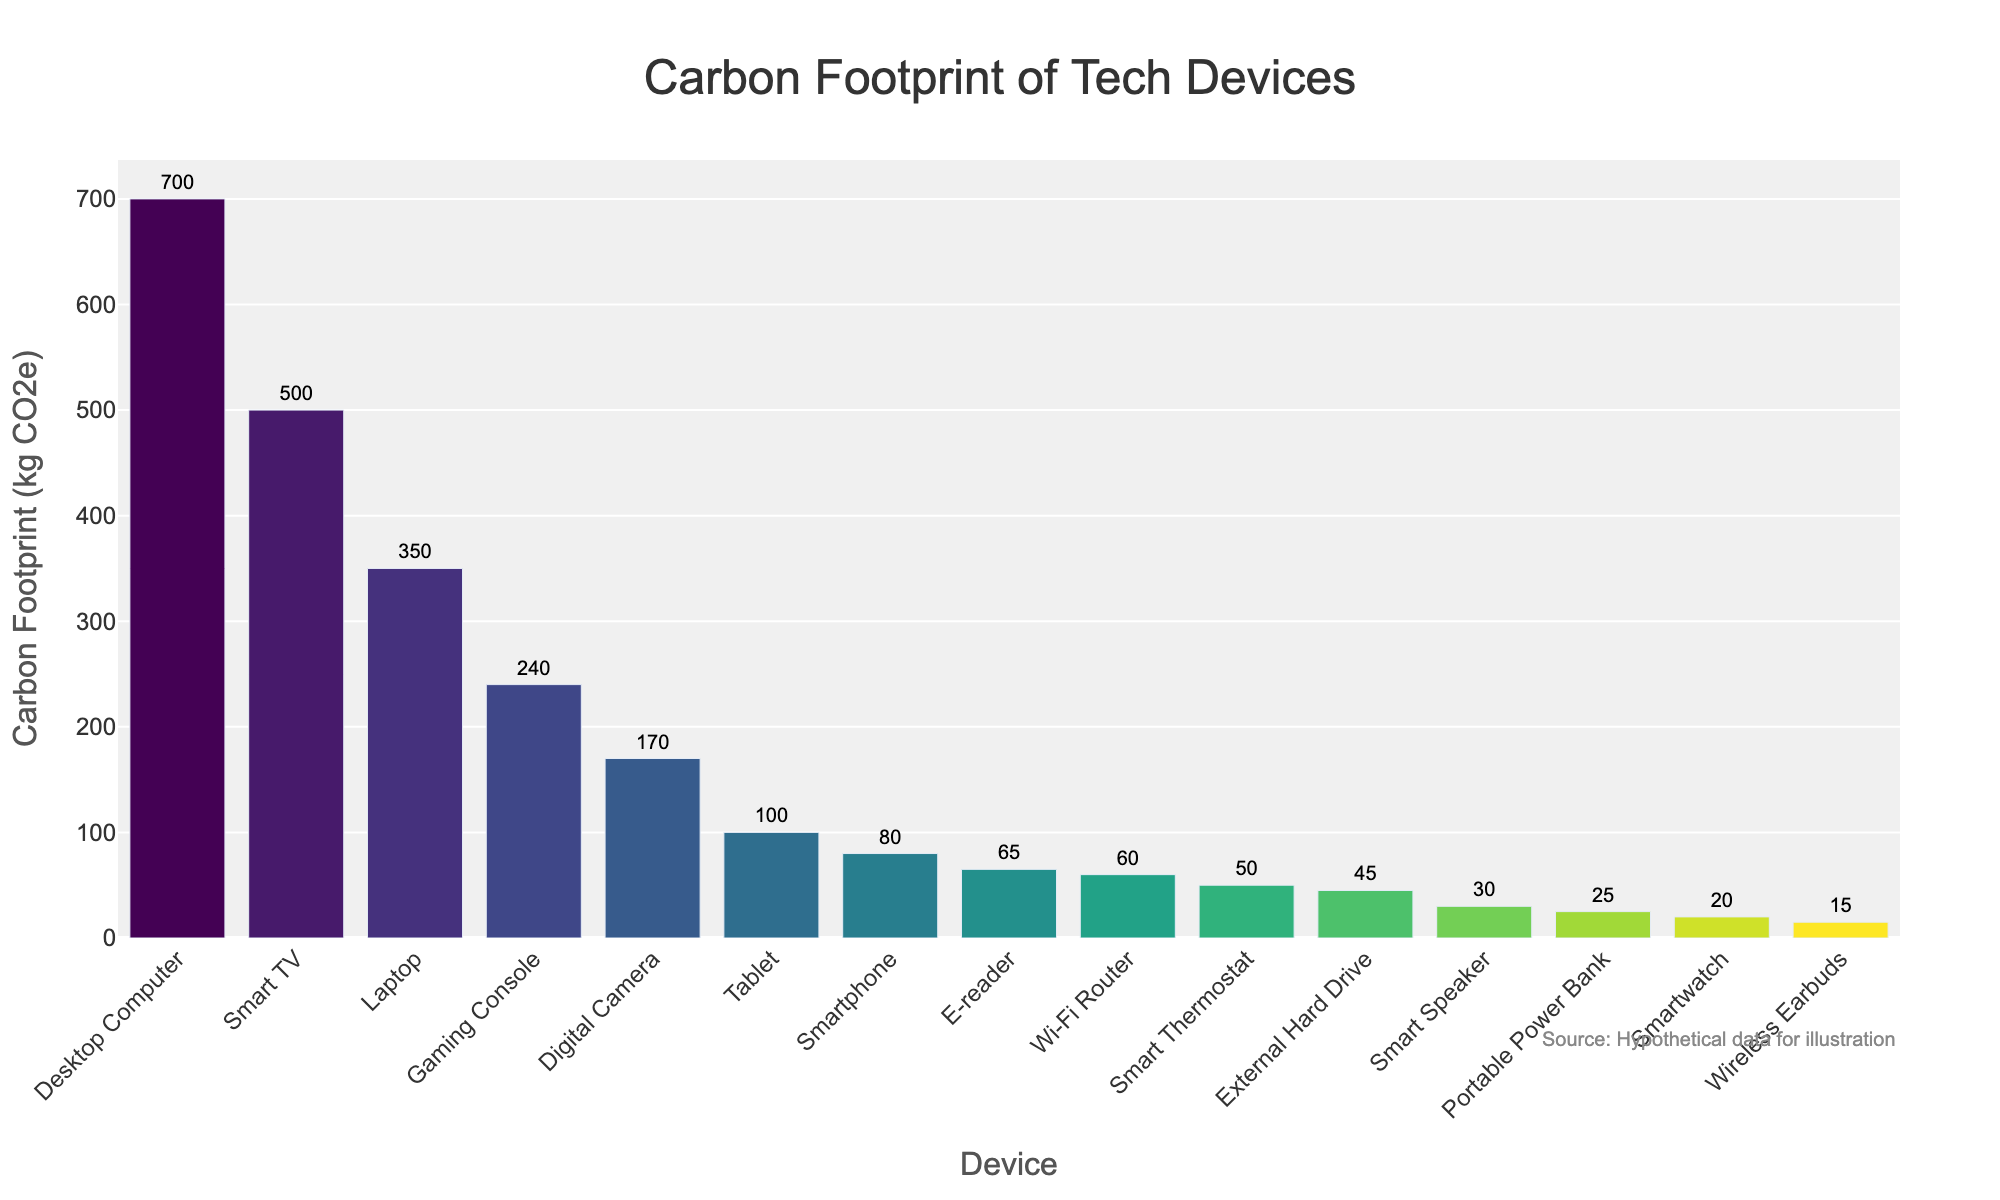Which device has the highest carbon footprint? The Desktop Computer is visually the tallest bar in the chart, indicating the highest carbon footprint.
Answer: Desktop Computer Which device has the lowest carbon footprint? The Smartwatch has the shortest bar in the chart, indicating the lowest carbon footprint.
Answer: Smartwatch What is the difference in carbon footprint between a Laptop and a Tablet? A Laptop has a carbon footprint of 350 kg CO2e, and a Tablet has 100 kg CO2e. The difference is 350 - 100 = 250 kg CO2e.
Answer: 250 kg CO2e Which device has a higher carbon footprint: a Smart TV or a Gaming Console? The bar for Smart TV is taller than the bar for Gaming Console. Therefore, the Smart TV has a higher carbon footprint.
Answer: Smart TV What is the sum of the carbon footprints of a Digital Camera and an E-reader? The Digital Camera has a carbon footprint of 170 kg CO2e, and the E-reader has 65 kg CO2e. The sum is 170 + 65 = 235 kg CO2e.
Answer: 235 kg CO2e What is the average carbon footprint of all devices listed? Total carbon footprint is obtained by summing the values. (80 + 350 + 700 + 100 + 500 + 20 + 240 + 65 + 15 + 30 + 170 + 25 + 60 + 45 + 50) = 2450 kg CO2e. There are 15 devices, so the average is 2450 / 15 = 163.33 kg CO2e.
Answer: 163.33 kg CO2e Which category does the Wi-Fi Router fall in: top 5 highest or bottom 5 lowest carbon footprints? The Wi-Fi Router's bar is shorter than many others but not quite at the bottom. By observing the heights, it falls in the bottom 5 lowest category.
Answer: Bottom 5 lowest Which devices have a carbon footprint between 50 and 250 kg CO2e? The bars for E-reader (65), Wi-Fi Router (60), External Hard Drive (45), Smart Thermostat (50), and Gaming Console (240) all fall between 50 and 250 kg CO2e.
Answer: E-reader, Wi-Fi Router, External Hard Drive, Smart Thermostat, Gaming Console Which device among Smartwatch, Wireless Earbuds, and Portable Power Bank has the highest carbon footprint? Among these, the Portable Power Bank has the highest carbon footprint as its bar is the tallest compared to the other two.
Answer: Portable Power Bank What is the median carbon footprint value of the devices? First, list the carbon footprints in ascending order: 15, 20, 25, 30, 45, 50, 60, 65, 80, 100, 170, 240, 350, 500, 700. With 15 values, the median is the middle value, i.e., 7th value. The median carbon footprint is 65 kg CO2e.
Answer: 65 kg CO2e 